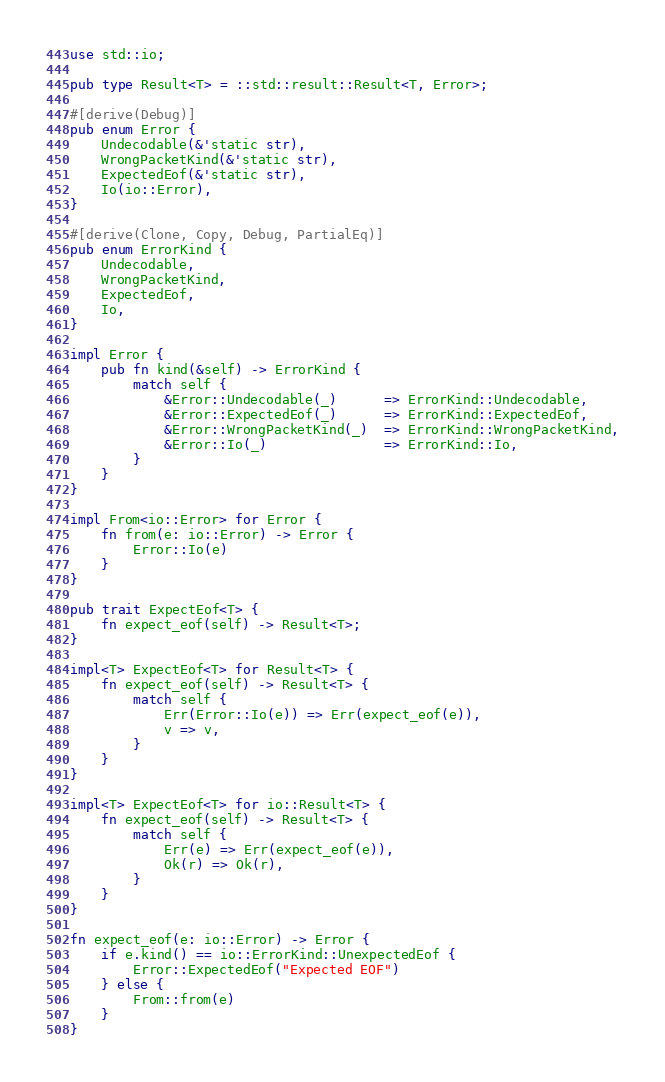Convert code to text. <code><loc_0><loc_0><loc_500><loc_500><_Rust_>use std::io;

pub type Result<T> = ::std::result::Result<T, Error>;

#[derive(Debug)]
pub enum Error {
    Undecodable(&'static str),
    WrongPacketKind(&'static str),
    ExpectedEof(&'static str),
    Io(io::Error),
}

#[derive(Clone, Copy, Debug, PartialEq)]
pub enum ErrorKind {
    Undecodable,
    WrongPacketKind,
    ExpectedEof,
    Io,
}

impl Error {
    pub fn kind(&self) -> ErrorKind {
        match self {
            &Error::Undecodable(_)      => ErrorKind::Undecodable,
            &Error::ExpectedEof(_)      => ErrorKind::ExpectedEof,
            &Error::WrongPacketKind(_)  => ErrorKind::WrongPacketKind,
            &Error::Io(_)               => ErrorKind::Io,
        }
    }
}

impl From<io::Error> for Error {
    fn from(e: io::Error) -> Error {
        Error::Io(e)
    }
}

pub trait ExpectEof<T> {
    fn expect_eof(self) -> Result<T>;
}

impl<T> ExpectEof<T> for Result<T> {
    fn expect_eof(self) -> Result<T> {
        match self {
            Err(Error::Io(e)) => Err(expect_eof(e)),
            v => v,
        }
    }
}

impl<T> ExpectEof<T> for io::Result<T> {
    fn expect_eof(self) -> Result<T> {
        match self {
            Err(e) => Err(expect_eof(e)),
            Ok(r) => Ok(r),
        }
    }
}

fn expect_eof(e: io::Error) -> Error {
    if e.kind() == io::ErrorKind::UnexpectedEof {
        Error::ExpectedEof("Expected EOF")
    } else {
        From::from(e)
    }
}</code> 